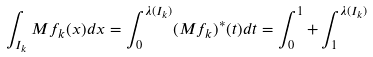Convert formula to latex. <formula><loc_0><loc_0><loc_500><loc_500>\int _ { I _ { k } } M f _ { k } ( x ) d x = \int _ { 0 } ^ { \lambda ( I _ { k } ) } ( M f _ { k } ) ^ { * } ( t ) d t = \int _ { 0 } ^ { 1 } + \int _ { 1 } ^ { \lambda ( I _ { k } ) }</formula> 